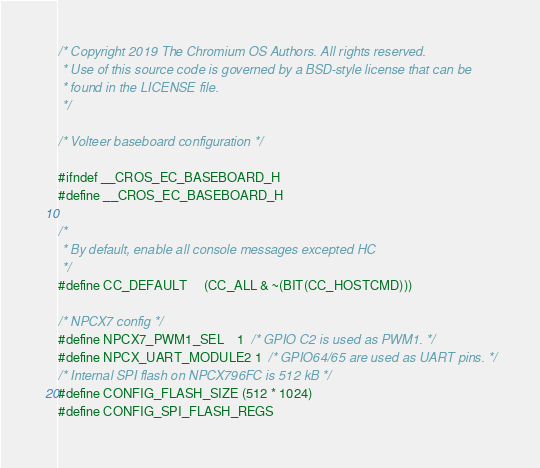<code> <loc_0><loc_0><loc_500><loc_500><_C_>/* Copyright 2019 The Chromium OS Authors. All rights reserved.
 * Use of this source code is governed by a BSD-style license that can be
 * found in the LICENSE file.
 */

/* Volteer baseboard configuration */

#ifndef __CROS_EC_BASEBOARD_H
#define __CROS_EC_BASEBOARD_H

/*
 * By default, enable all console messages excepted HC
 */
#define CC_DEFAULT     (CC_ALL & ~(BIT(CC_HOSTCMD)))

/* NPCX7 config */
#define NPCX7_PWM1_SEL    1  /* GPIO C2 is used as PWM1. */
#define NPCX_UART_MODULE2 1  /* GPIO64/65 are used as UART pins. */
/* Internal SPI flash on NPCX796FC is 512 kB */
#define CONFIG_FLASH_SIZE (512 * 1024)
#define CONFIG_SPI_FLASH_REGS</code> 